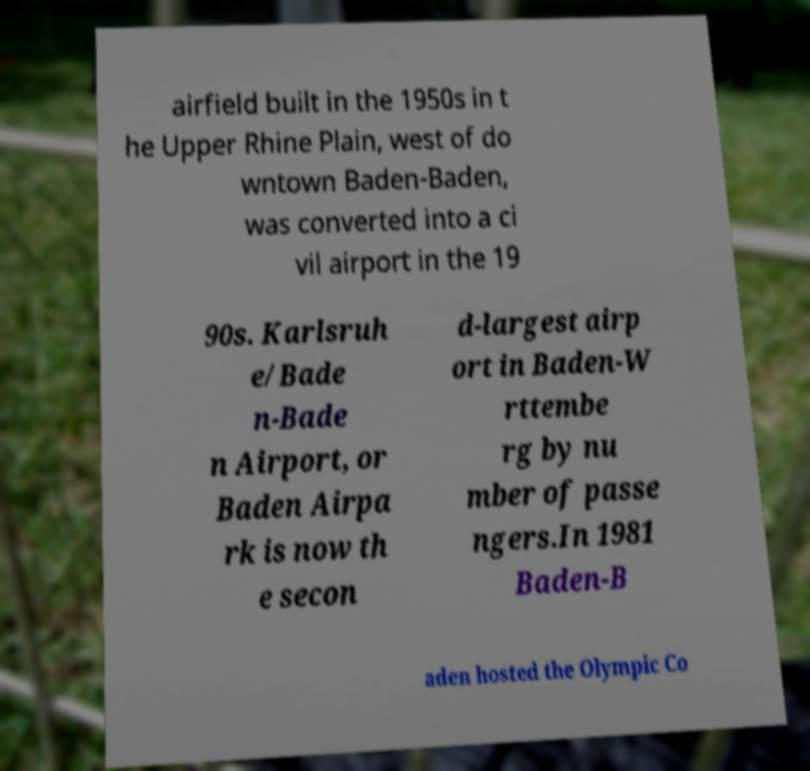I need the written content from this picture converted into text. Can you do that? airfield built in the 1950s in t he Upper Rhine Plain, west of do wntown Baden-Baden, was converted into a ci vil airport in the 19 90s. Karlsruh e/Bade n-Bade n Airport, or Baden Airpa rk is now th e secon d-largest airp ort in Baden-W rttembe rg by nu mber of passe ngers.In 1981 Baden-B aden hosted the Olympic Co 